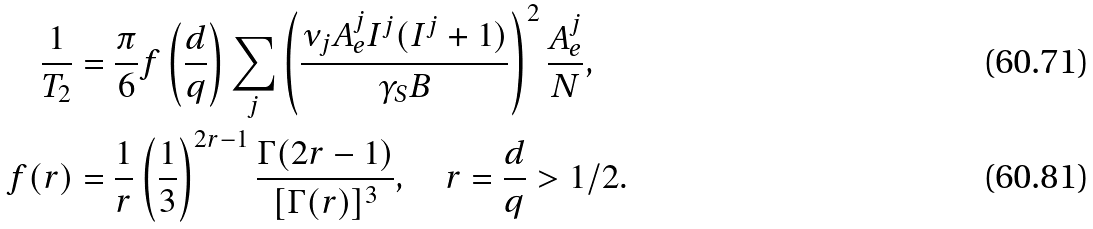<formula> <loc_0><loc_0><loc_500><loc_500>\frac { 1 } { T _ { 2 } } & = \frac { \pi } { 6 } f \left ( \frac { d } { q } \right ) \sum _ { j } \left ( \frac { \nu _ { j } A _ { e } ^ { j } I ^ { j } ( I ^ { j } + 1 ) } { \gamma _ { S } B } \right ) ^ { 2 } \frac { A _ { e } ^ { j } } { N } , \\ f ( r ) & = \frac { 1 } { r } \left ( \frac { 1 } { 3 } \right ) ^ { 2 r - 1 } \frac { \Gamma ( 2 r - 1 ) } { [ \Gamma ( r ) ] ^ { 3 } } , \quad r = \frac { d } { q } > 1 / 2 .</formula> 